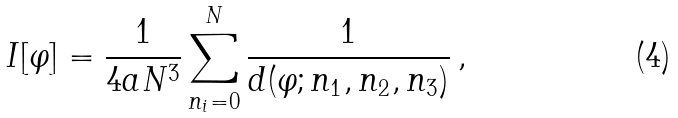Convert formula to latex. <formula><loc_0><loc_0><loc_500><loc_500>I [ \varphi ] = \frac { 1 } { 4 a N ^ { 3 } } \sum ^ { N } _ { n _ { i } = 0 } \frac { 1 } { d ( \varphi ; n _ { 1 } , n _ { 2 } , n _ { 3 } ) } \, ,</formula> 